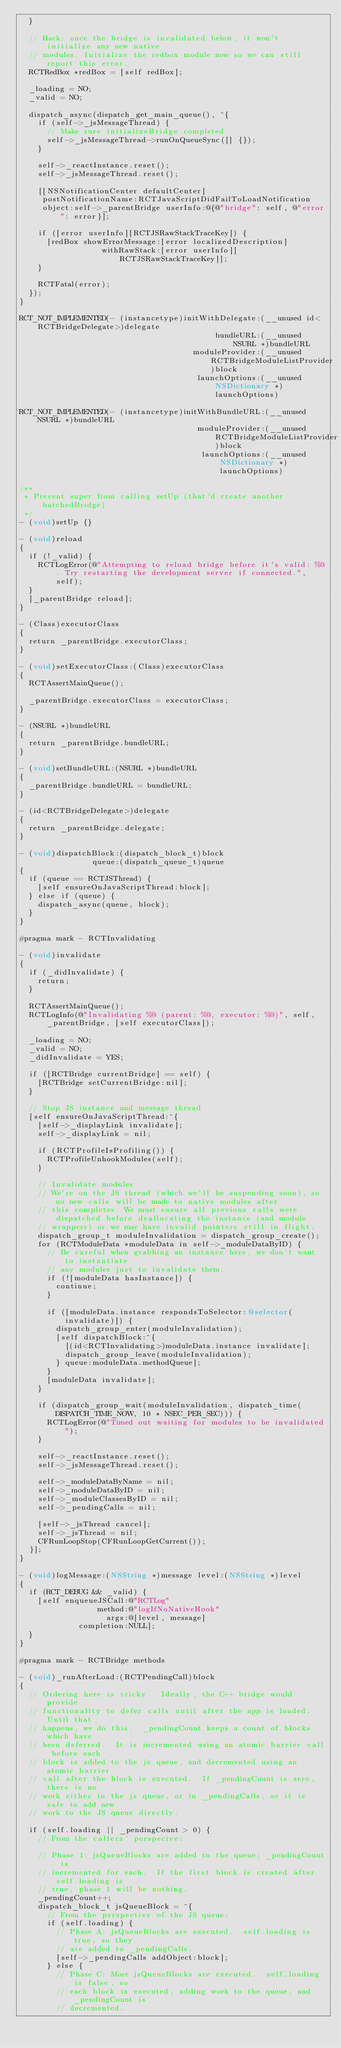<code> <loc_0><loc_0><loc_500><loc_500><_ObjectiveC_>  }

  // Hack: once the bridge is invalidated below, it won't initialize any new native
  // modules. Initialize the redbox module now so we can still report this error.
  RCTRedBox *redBox = [self redBox];

  _loading = NO;
  _valid = NO;

  dispatch_async(dispatch_get_main_queue(), ^{
    if (self->_jsMessageThread) {
      // Make sure initializeBridge completed
      self->_jsMessageThread->runOnQueueSync([] {});
    }

    self->_reactInstance.reset();
    self->_jsMessageThread.reset();

    [[NSNotificationCenter defaultCenter]
     postNotificationName:RCTJavaScriptDidFailToLoadNotification
     object:self->_parentBridge userInfo:@{@"bridge": self, @"error": error}];

    if ([error userInfo][RCTJSRawStackTraceKey]) {
      [redBox showErrorMessage:[error localizedDescription]
                  withRawStack:[error userInfo][RCTJSRawStackTraceKey]];
    }

    RCTFatal(error);
  });
}

RCT_NOT_IMPLEMENTED(- (instancetype)initWithDelegate:(__unused id<RCTBridgeDelegate>)delegate
                                           bundleURL:(__unused NSURL *)bundleURL
                                      moduleProvider:(__unused RCTBridgeModuleListProvider)block
                                       launchOptions:(__unused NSDictionary *)launchOptions)

RCT_NOT_IMPLEMENTED(- (instancetype)initWithBundleURL:(__unused NSURL *)bundleURL
                                       moduleProvider:(__unused RCTBridgeModuleListProvider)block
                                        launchOptions:(__unused NSDictionary *)launchOptions)

/**
 * Prevent super from calling setUp (that'd create another batchedBridge)
 */
- (void)setUp {}

- (void)reload
{
  if (!_valid) {
    RCTLogError(@"Attempting to reload bridge before it's valid: %@. Try restarting the development server if connected.", self);
  }
  [_parentBridge reload];
}

- (Class)executorClass
{
  return _parentBridge.executorClass;
}

- (void)setExecutorClass:(Class)executorClass
{
  RCTAssertMainQueue();

  _parentBridge.executorClass = executorClass;
}

- (NSURL *)bundleURL
{
  return _parentBridge.bundleURL;
}

- (void)setBundleURL:(NSURL *)bundleURL
{
  _parentBridge.bundleURL = bundleURL;
}

- (id<RCTBridgeDelegate>)delegate
{
  return _parentBridge.delegate;
}

- (void)dispatchBlock:(dispatch_block_t)block
                queue:(dispatch_queue_t)queue
{
  if (queue == RCTJSThread) {
    [self ensureOnJavaScriptThread:block];
  } else if (queue) {
    dispatch_async(queue, block);
  }
}

#pragma mark - RCTInvalidating

- (void)invalidate
{
  if (_didInvalidate) {
    return;
  }

  RCTAssertMainQueue();
  RCTLogInfo(@"Invalidating %@ (parent: %@, executor: %@)", self, _parentBridge, [self executorClass]);

  _loading = NO;
  _valid = NO;
  _didInvalidate = YES;

  if ([RCTBridge currentBridge] == self) {
    [RCTBridge setCurrentBridge:nil];
  }

  // Stop JS instance and message thread
  [self ensureOnJavaScriptThread:^{
    [self->_displayLink invalidate];
    self->_displayLink = nil;

    if (RCTProfileIsProfiling()) {
      RCTProfileUnhookModules(self);
    }

    // Invalidate modules
    // We're on the JS thread (which we'll be suspending soon), so no new calls will be made to native modules after
    // this completes. We must ensure all previous calls were dispatched before deallocating the instance (and module
    // wrappers) or we may have invalid pointers still in flight.
    dispatch_group_t moduleInvalidation = dispatch_group_create();
    for (RCTModuleData *moduleData in self->_moduleDataByID) {
      // Be careful when grabbing an instance here, we don't want to instantiate
      // any modules just to invalidate them.
      if (![moduleData hasInstance]) {
        continue;
      }

      if ([moduleData.instance respondsToSelector:@selector(invalidate)]) {
        dispatch_group_enter(moduleInvalidation);
        [self dispatchBlock:^{
          [(id<RCTInvalidating>)moduleData.instance invalidate];
          dispatch_group_leave(moduleInvalidation);
        } queue:moduleData.methodQueue];
      }
      [moduleData invalidate];
    }

    if (dispatch_group_wait(moduleInvalidation, dispatch_time(DISPATCH_TIME_NOW, 10 * NSEC_PER_SEC))) {
      RCTLogError(@"Timed out waiting for modules to be invalidated");
    }

    self->_reactInstance.reset();
    self->_jsMessageThread.reset();

    self->_moduleDataByName = nil;
    self->_moduleDataByID = nil;
    self->_moduleClassesByID = nil;
    self->_pendingCalls = nil;

    [self->_jsThread cancel];
    self->_jsThread = nil;
    CFRunLoopStop(CFRunLoopGetCurrent());
  }];
}

- (void)logMessage:(NSString *)message level:(NSString *)level
{
  if (RCT_DEBUG && _valid) {
    [self enqueueJSCall:@"RCTLog"
                 method:@"logIfNoNativeHook"
                   args:@[level, message]
             completion:NULL];
  }
}

#pragma mark - RCTBridge methods

- (void)_runAfterLoad:(RCTPendingCall)block
{
  // Ordering here is tricky.  Ideally, the C++ bridge would provide
  // functionality to defer calls until after the app is loaded.  Until that
  // happens, we do this.  _pendingCount keeps a count of blocks which have
  // been deferred.  It is incremented using an atomic barrier call before each
  // block is added to the js queue, and decremented using an atomic barrier
  // call after the block is executed.  If _pendingCount is zero, there is no
  // work either in the js queue, or in _pendingCalls, so it is safe to add new
  // work to the JS queue directly.

  if (self.loading || _pendingCount > 0) {
    // From the callers' perspecive:

    // Phase 1: jsQueueBlocks are added to the queue; _pendingCount is
    // incremented for each.  If the first block is created after self.loading is
    // true, phase 1 will be nothing.
    _pendingCount++;
    dispatch_block_t jsQueueBlock = ^{
      // From the perspective of the JS queue:
      if (self.loading) {
        // Phase A: jsQueueBlocks are executed.  self.loading is true, so they
        // are added to _pendingCalls.
        [self->_pendingCalls addObject:block];
      } else {
        // Phase C: More jsQueueBlocks are executed.  self.loading is false, so
        // each block is executed, adding work to the queue, and _pendingCount is
        // decremented.</code> 